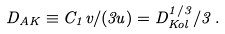Convert formula to latex. <formula><loc_0><loc_0><loc_500><loc_500>D _ { A K } \equiv C _ { 1 } v / ( 3 u ) = D _ { K o l } ^ { 1 / 3 } / 3 \, .</formula> 